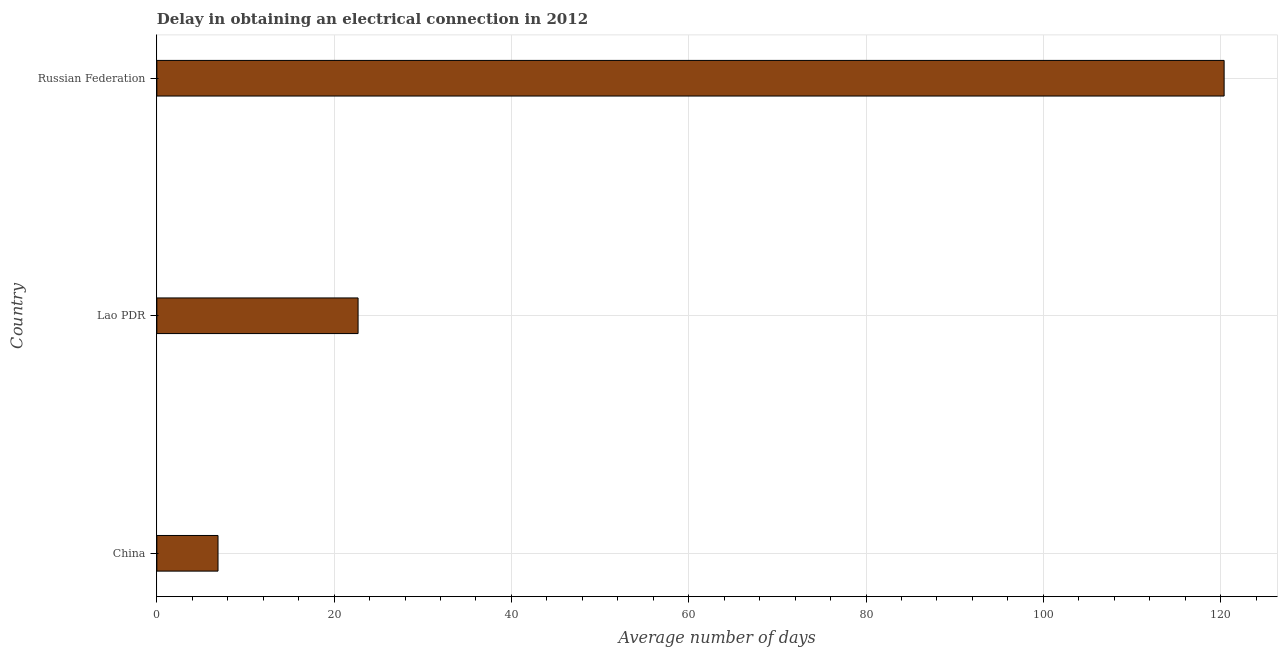Does the graph contain any zero values?
Give a very brief answer. No. Does the graph contain grids?
Provide a short and direct response. Yes. What is the title of the graph?
Keep it short and to the point. Delay in obtaining an electrical connection in 2012. What is the label or title of the X-axis?
Provide a short and direct response. Average number of days. What is the label or title of the Y-axis?
Provide a succinct answer. Country. What is the dalay in electrical connection in Lao PDR?
Provide a short and direct response. 22.7. Across all countries, what is the maximum dalay in electrical connection?
Make the answer very short. 120.4. In which country was the dalay in electrical connection maximum?
Offer a very short reply. Russian Federation. What is the sum of the dalay in electrical connection?
Ensure brevity in your answer.  150. What is the difference between the dalay in electrical connection in China and Russian Federation?
Make the answer very short. -113.5. What is the average dalay in electrical connection per country?
Give a very brief answer. 50. What is the median dalay in electrical connection?
Ensure brevity in your answer.  22.7. In how many countries, is the dalay in electrical connection greater than 52 days?
Offer a very short reply. 1. What is the ratio of the dalay in electrical connection in China to that in Russian Federation?
Keep it short and to the point. 0.06. Is the dalay in electrical connection in China less than that in Lao PDR?
Provide a succinct answer. Yes. Is the difference between the dalay in electrical connection in Lao PDR and Russian Federation greater than the difference between any two countries?
Provide a succinct answer. No. What is the difference between the highest and the second highest dalay in electrical connection?
Provide a short and direct response. 97.7. What is the difference between the highest and the lowest dalay in electrical connection?
Make the answer very short. 113.5. Are all the bars in the graph horizontal?
Make the answer very short. Yes. What is the difference between two consecutive major ticks on the X-axis?
Provide a succinct answer. 20. What is the Average number of days of China?
Offer a terse response. 6.9. What is the Average number of days of Lao PDR?
Keep it short and to the point. 22.7. What is the Average number of days of Russian Federation?
Your answer should be compact. 120.4. What is the difference between the Average number of days in China and Lao PDR?
Make the answer very short. -15.8. What is the difference between the Average number of days in China and Russian Federation?
Make the answer very short. -113.5. What is the difference between the Average number of days in Lao PDR and Russian Federation?
Ensure brevity in your answer.  -97.7. What is the ratio of the Average number of days in China to that in Lao PDR?
Keep it short and to the point. 0.3. What is the ratio of the Average number of days in China to that in Russian Federation?
Your answer should be very brief. 0.06. What is the ratio of the Average number of days in Lao PDR to that in Russian Federation?
Provide a short and direct response. 0.19. 